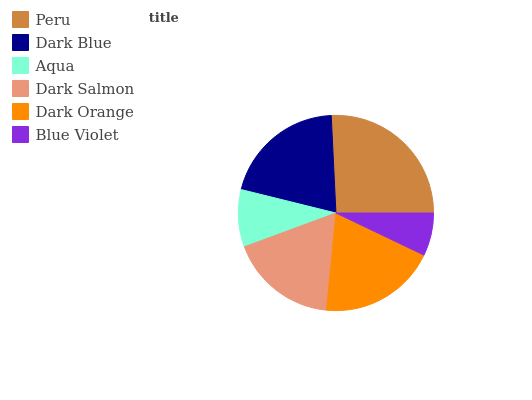Is Blue Violet the minimum?
Answer yes or no. Yes. Is Peru the maximum?
Answer yes or no. Yes. Is Dark Blue the minimum?
Answer yes or no. No. Is Dark Blue the maximum?
Answer yes or no. No. Is Peru greater than Dark Blue?
Answer yes or no. Yes. Is Dark Blue less than Peru?
Answer yes or no. Yes. Is Dark Blue greater than Peru?
Answer yes or no. No. Is Peru less than Dark Blue?
Answer yes or no. No. Is Dark Orange the high median?
Answer yes or no. Yes. Is Dark Salmon the low median?
Answer yes or no. Yes. Is Aqua the high median?
Answer yes or no. No. Is Dark Blue the low median?
Answer yes or no. No. 